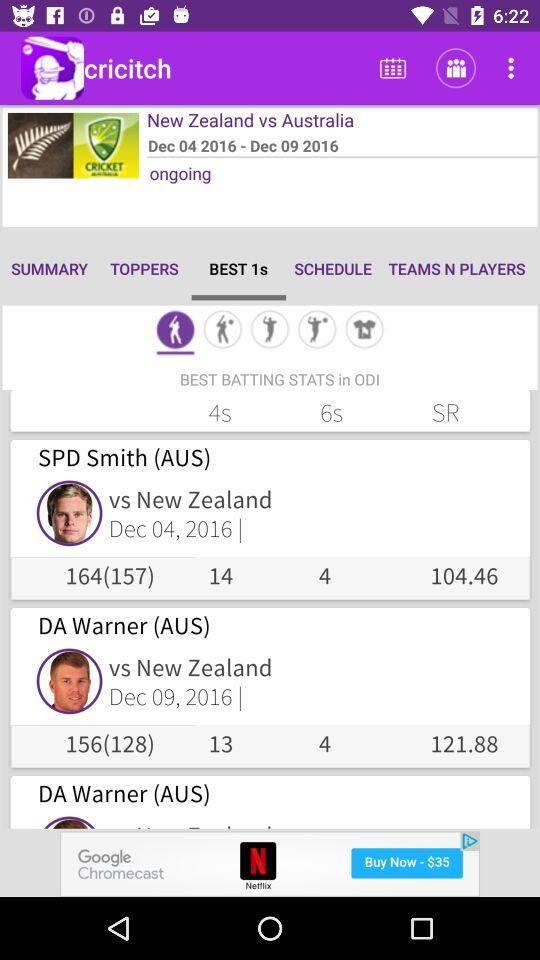How many runs did Smith score against New Zealand? Smith scored 164 runs against New Zealand. 